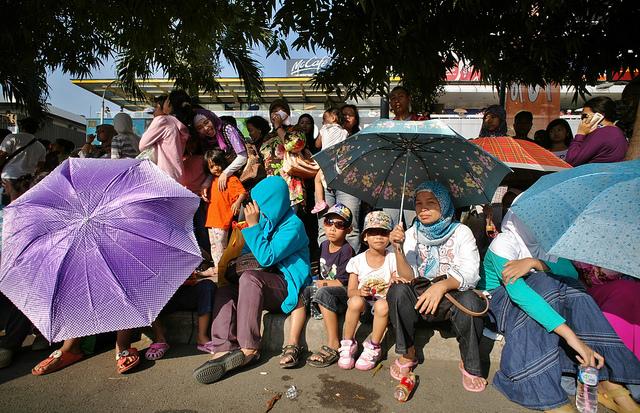Why are some holding umbrellas?
Write a very short answer. Sun. Do these people seem to be waiting for something?
Give a very brief answer. Yes. What color is the umbrella on the left?
Be succinct. Purple. Is it raining?
Concise answer only. No. 